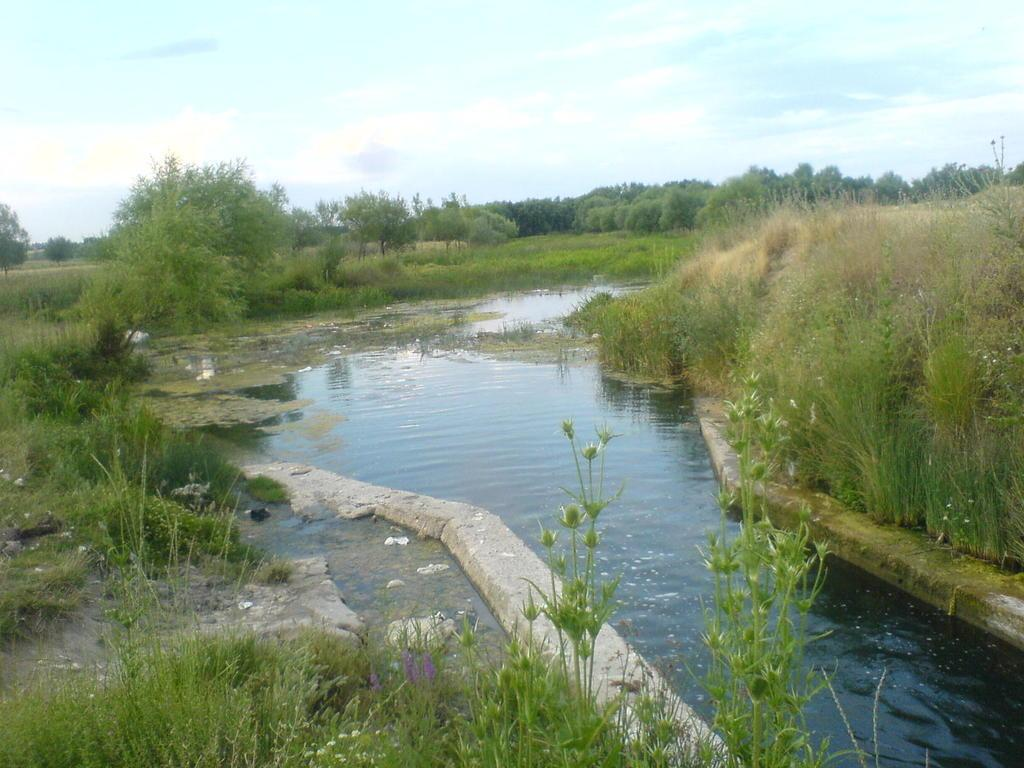What is the primary element present in the image? There is water in the image. What type of vegetation can be seen in the image? There are bushes and multiple trees in the image. What is visible in the background of the image? Clouds and the sky are visible in the background of the image. What type of pot is being used to weigh the pail in the image? There is no pot or pail present in the image. What scale is being used to measure the weight of the bushes in the image? There is no scale or measurement of bushes in the image. 